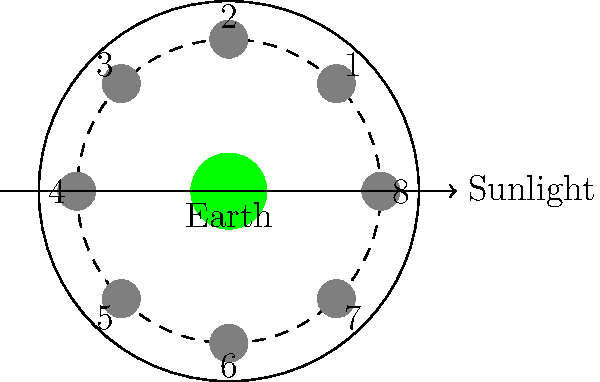Remember those nights we used to listen to Baccara's "Yes Sir, I Can Boogie" while stargazing? Let's relive those memories! Look at the moon phase diagram above, where the Earth is at the center and the moon's positions are numbered 1-8. At which numbered position would the moon appear as a waxing gibbous phase from Earth? Let's break this down step-by-step, just like we used to analyze Baccara's lyrics:

1. First, recall that the moon's phases are caused by the changing angles between the Earth, moon, and Sun.

2. The diagram shows the Sun's light coming from the right side, as indicated by the arrow.

3. A waxing gibbous moon occurs when more than half, but not all, of the moon's illuminated surface is visible from Earth, and the illuminated portion is increasing.

4. Let's go through the positions:
   - Position 1: New Moon (not visible)
   - Position 3: Waxing Crescent
   - Position 5: First Quarter (half moon)
   - Position 7: Full Moon

5. The waxing gibbous phase occurs between the First Quarter and Full Moon.

6. Therefore, it must be at position 6, where more than half of the illuminated surface is visible from Earth, and it's still growing towards a Full Moon.

Just like Baccara's music evolved from "Yes Sir, I Can Boogie" to their later hits, the moon progresses through its phases, with the waxing gibbous being a beautiful prelude to the full moon!
Answer: 6 